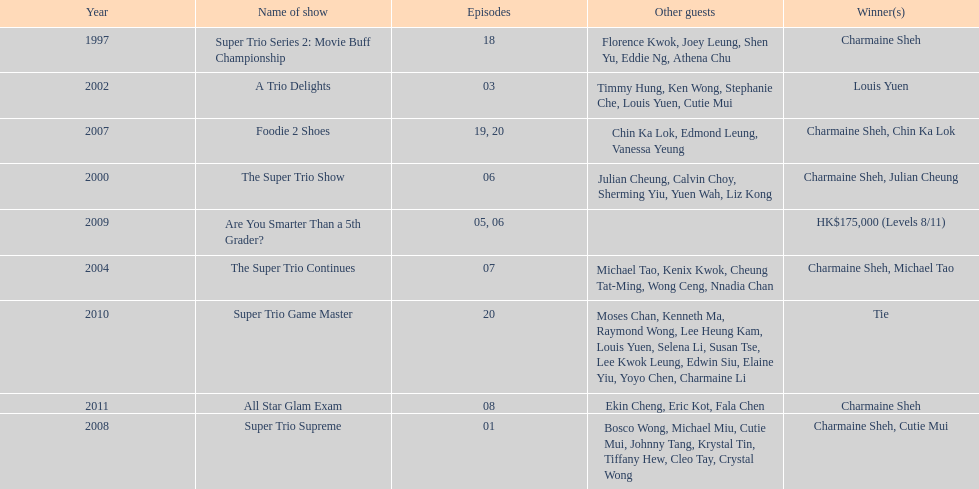How many episodes was charmaine sheh on in the variety show super trio 2: movie buff champions 18. I'm looking to parse the entire table for insights. Could you assist me with that? {'header': ['Year', 'Name of show', 'Episodes', 'Other guests', 'Winner(s)'], 'rows': [['1997', 'Super Trio Series 2: Movie Buff Championship', '18', 'Florence Kwok, Joey Leung, Shen Yu, Eddie Ng, Athena Chu', 'Charmaine Sheh'], ['2002', 'A Trio Delights', '03', 'Timmy Hung, Ken Wong, Stephanie Che, Louis Yuen, Cutie Mui', 'Louis Yuen'], ['2007', 'Foodie 2 Shoes', '19, 20', 'Chin Ka Lok, Edmond Leung, Vanessa Yeung', 'Charmaine Sheh, Chin Ka Lok'], ['2000', 'The Super Trio Show', '06', 'Julian Cheung, Calvin Choy, Sherming Yiu, Yuen Wah, Liz Kong', 'Charmaine Sheh, Julian Cheung'], ['2009', 'Are You Smarter Than a 5th Grader?', '05, 06', '', 'HK$175,000 (Levels 8/11)'], ['2004', 'The Super Trio Continues', '07', 'Michael Tao, Kenix Kwok, Cheung Tat-Ming, Wong Ceng, Nnadia Chan', 'Charmaine Sheh, Michael Tao'], ['2010', 'Super Trio Game Master', '20', 'Moses Chan, Kenneth Ma, Raymond Wong, Lee Heung Kam, Louis Yuen, Selena Li, Susan Tse, Lee Kwok Leung, Edwin Siu, Elaine Yiu, Yoyo Chen, Charmaine Li', 'Tie'], ['2011', 'All Star Glam Exam', '08', 'Ekin Cheng, Eric Kot, Fala Chen', 'Charmaine Sheh'], ['2008', 'Super Trio Supreme', '01', 'Bosco Wong, Michael Miu, Cutie Mui, Johnny Tang, Krystal Tin, Tiffany Hew, Cleo Tay, Crystal Wong', 'Charmaine Sheh, Cutie Mui']]} 